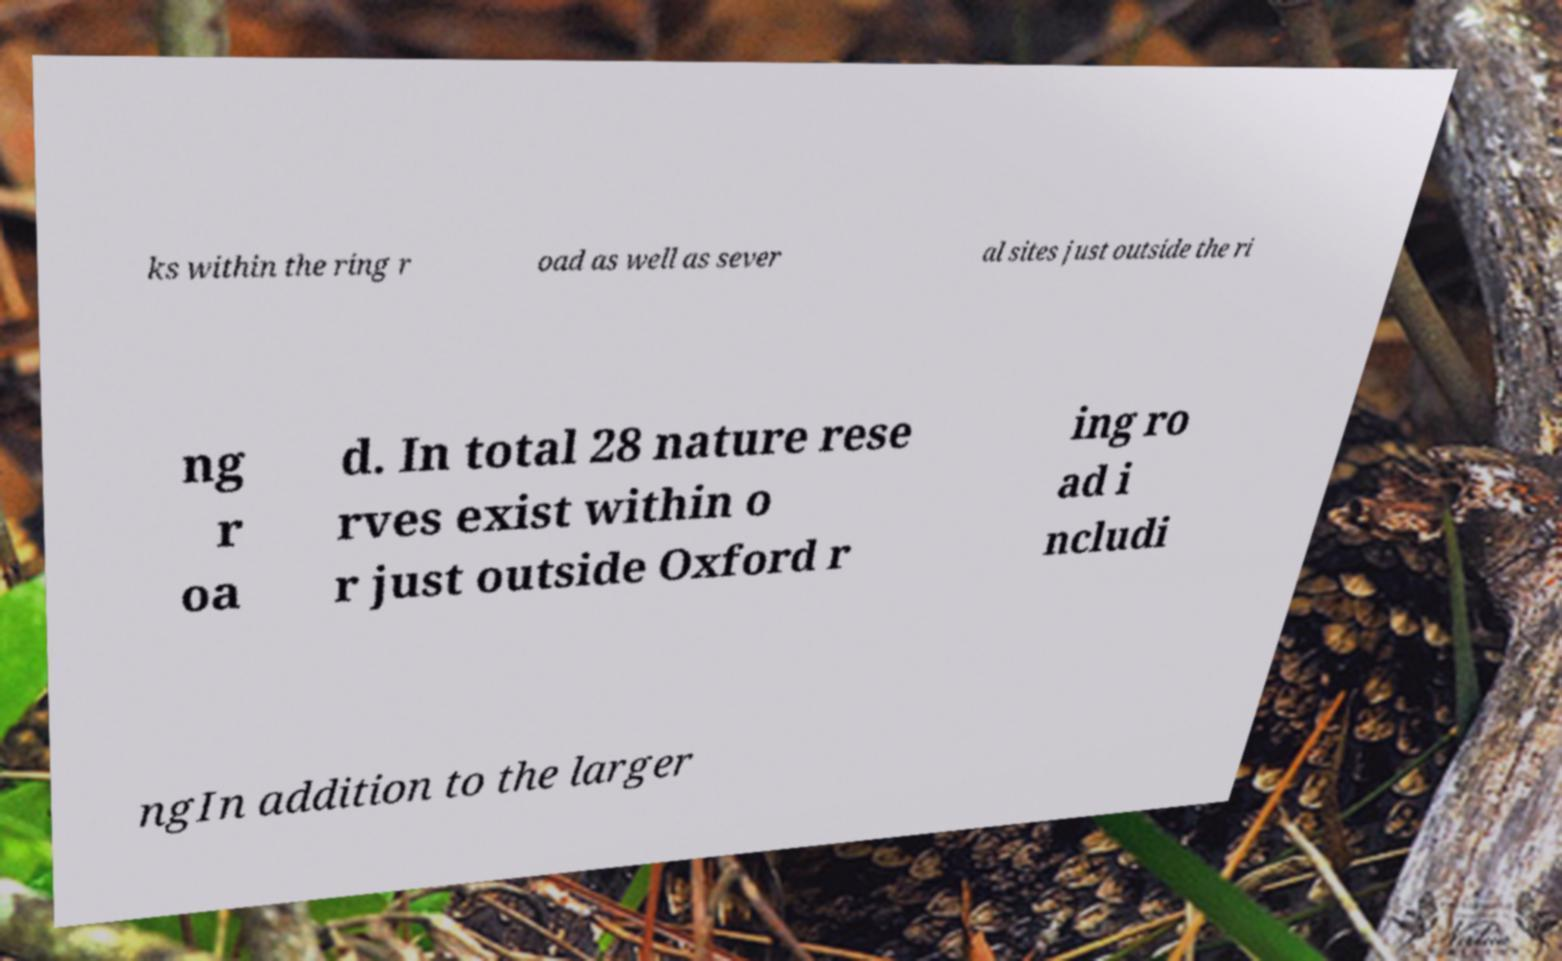Could you extract and type out the text from this image? ks within the ring r oad as well as sever al sites just outside the ri ng r oa d. In total 28 nature rese rves exist within o r just outside Oxford r ing ro ad i ncludi ngIn addition to the larger 